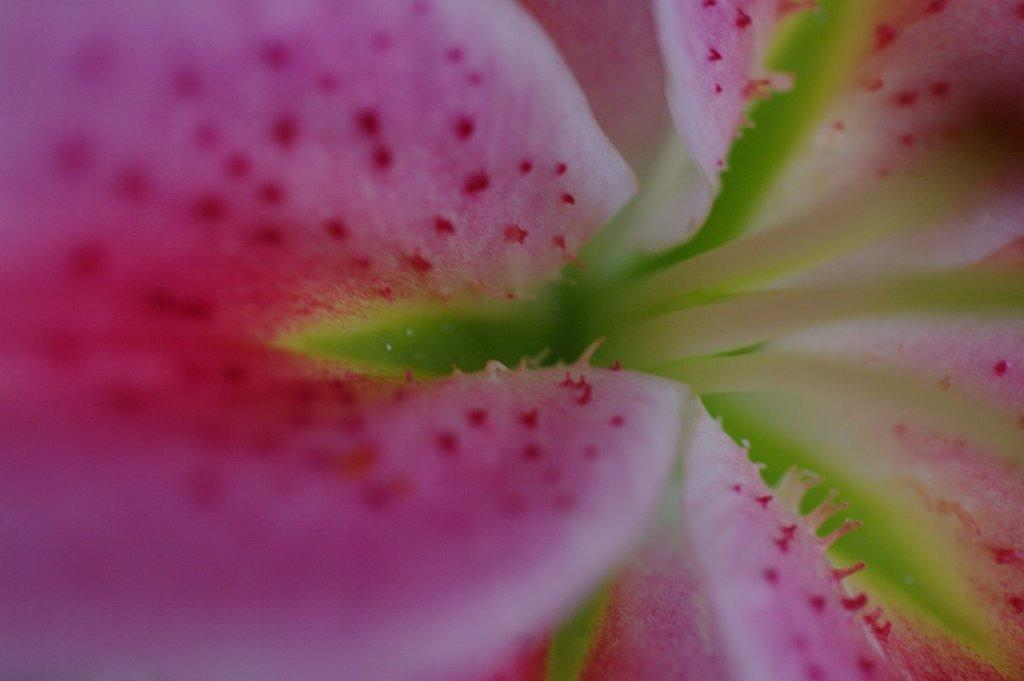What is the main subject of the image? There is a flower in the image. What color are the petals of the flower? The petals of the flower are in pink and green colors. How many wheels can be seen on the flower in the image? There are no wheels present in the image, as it features a flower with petals in pink and green colors. 